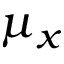<formula> <loc_0><loc_0><loc_500><loc_500>\mu _ { x }</formula> 